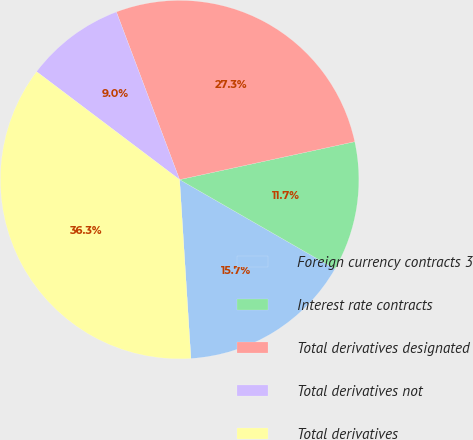<chart> <loc_0><loc_0><loc_500><loc_500><pie_chart><fcel>Foreign currency contracts 3<fcel>Interest rate contracts<fcel>Total derivatives designated<fcel>Total derivatives not<fcel>Total derivatives<nl><fcel>15.69%<fcel>11.7%<fcel>27.34%<fcel>8.97%<fcel>36.3%<nl></chart> 